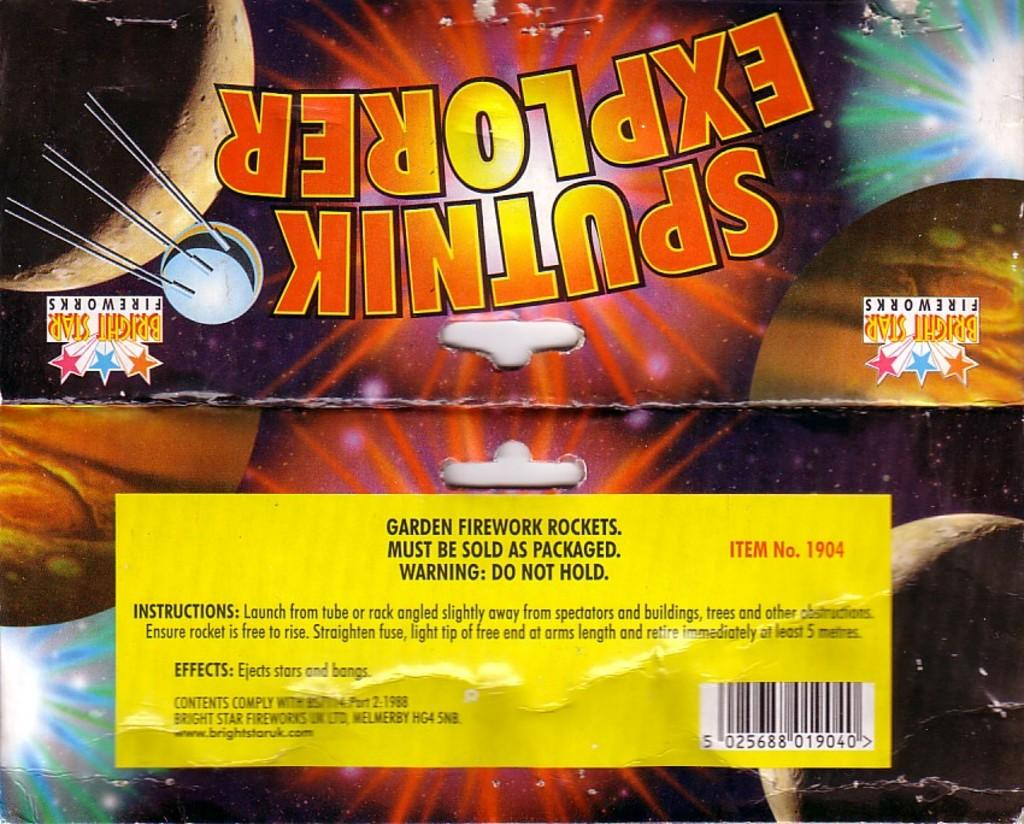Provide a one-sentence caption for the provided image. Spuntik explorer fireworks wrapper in bright colors with a yellow label on the back. 